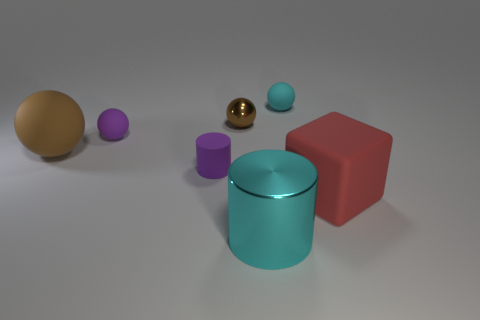There is a small purple thing behind the large thing that is to the left of the tiny rubber ball to the left of the tiny cyan sphere; what is its shape?
Your answer should be very brief. Sphere. What number of things are big yellow metallic spheres or big things that are behind the purple cylinder?
Keep it short and to the point. 1. There is a cyan object that is behind the big red block; how big is it?
Provide a succinct answer. Small. Does the large cyan object have the same material as the cylinder that is behind the big rubber cube?
Keep it short and to the point. No. There is a brown sphere in front of the shiny object behind the block; what number of tiny rubber balls are in front of it?
Provide a succinct answer. 0. How many purple objects are either large rubber cylinders or small matte spheres?
Make the answer very short. 1. The cyan object that is behind the purple matte sphere has what shape?
Offer a very short reply. Sphere. There is a rubber block that is the same size as the brown rubber ball; what color is it?
Provide a short and direct response. Red. There is a big cyan object; does it have the same shape as the large object that is on the left side of the tiny brown metallic ball?
Provide a succinct answer. No. There is a cyan object that is behind the large rubber thing behind the large rubber thing that is to the right of the small shiny ball; what is its material?
Keep it short and to the point. Rubber. 